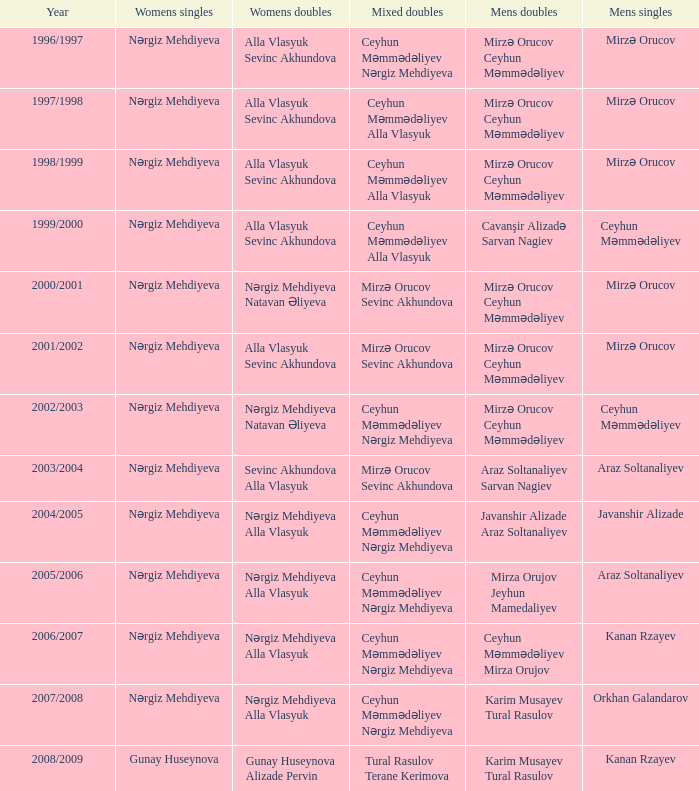What are all values for Womens Doubles in the year 2000/2001? Nərgiz Mehdiyeva Natavan Əliyeva. 